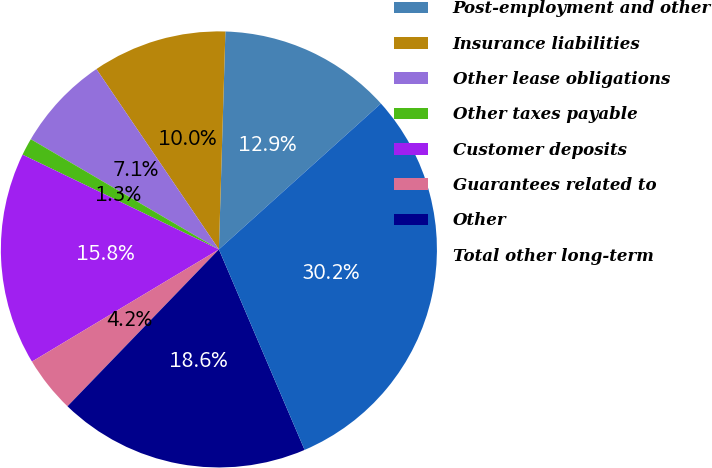<chart> <loc_0><loc_0><loc_500><loc_500><pie_chart><fcel>Post-employment and other<fcel>Insurance liabilities<fcel>Other lease obligations<fcel>Other taxes payable<fcel>Customer deposits<fcel>Guarantees related to<fcel>Other<fcel>Total other long-term<nl><fcel>12.86%<fcel>9.97%<fcel>7.07%<fcel>1.28%<fcel>15.76%<fcel>4.18%<fcel>18.65%<fcel>30.24%<nl></chart> 